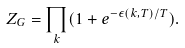<formula> <loc_0><loc_0><loc_500><loc_500>Z _ { G } = \prod _ { k } ( 1 + e ^ { - \epsilon ( k , T ) / T } ) .</formula> 